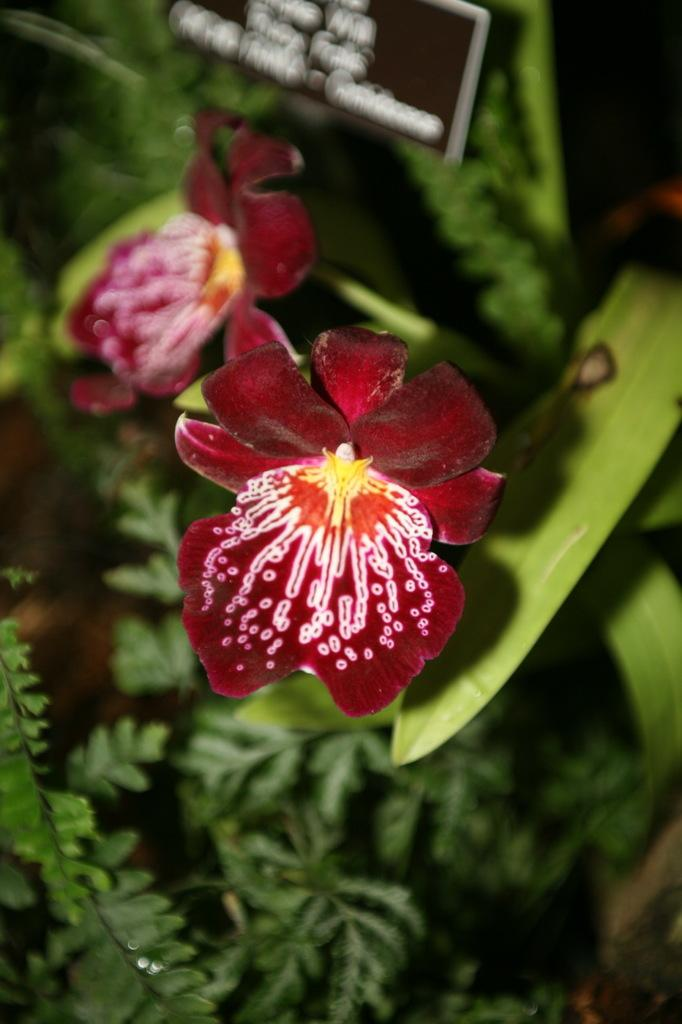What type of flower is on the plant in the image? There is a red color flower on a plant in the image. What else can be seen on the plant besides the flower? There are leaves on the plant. What is the color of the board at the top of the image? There is a black color board at the top of the image. What can be seen in the background of the image? There are plants visible in the background of the image. How many eyes can be seen on the flower in the image? There are no eyes visible on the flower in the image, as flowers do not have eyes. 